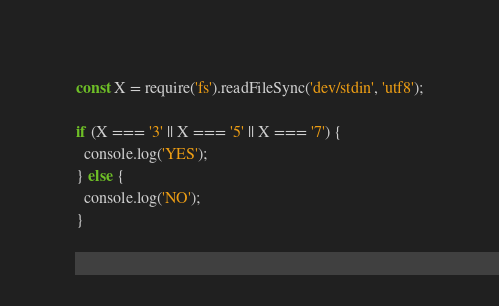Convert code to text. <code><loc_0><loc_0><loc_500><loc_500><_JavaScript_>const X = require('fs').readFileSync('dev/stdin', 'utf8');

if (X === '3' || X === '5' || X === '7') {
  console.log('YES');
} else {
  console.log('NO');
}</code> 